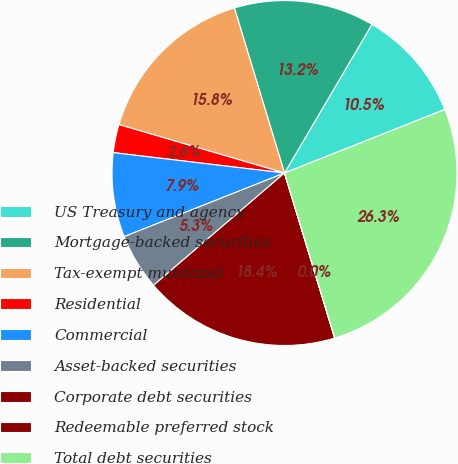Convert chart to OTSL. <chart><loc_0><loc_0><loc_500><loc_500><pie_chart><fcel>US Treasury and agency<fcel>Mortgage-backed securities<fcel>Tax-exempt municipal<fcel>Residential<fcel>Commercial<fcel>Asset-backed securities<fcel>Corporate debt securities<fcel>Redeemable preferred stock<fcel>Total debt securities<nl><fcel>10.53%<fcel>13.15%<fcel>15.78%<fcel>2.64%<fcel>7.9%<fcel>5.27%<fcel>18.41%<fcel>0.02%<fcel>26.29%<nl></chart> 